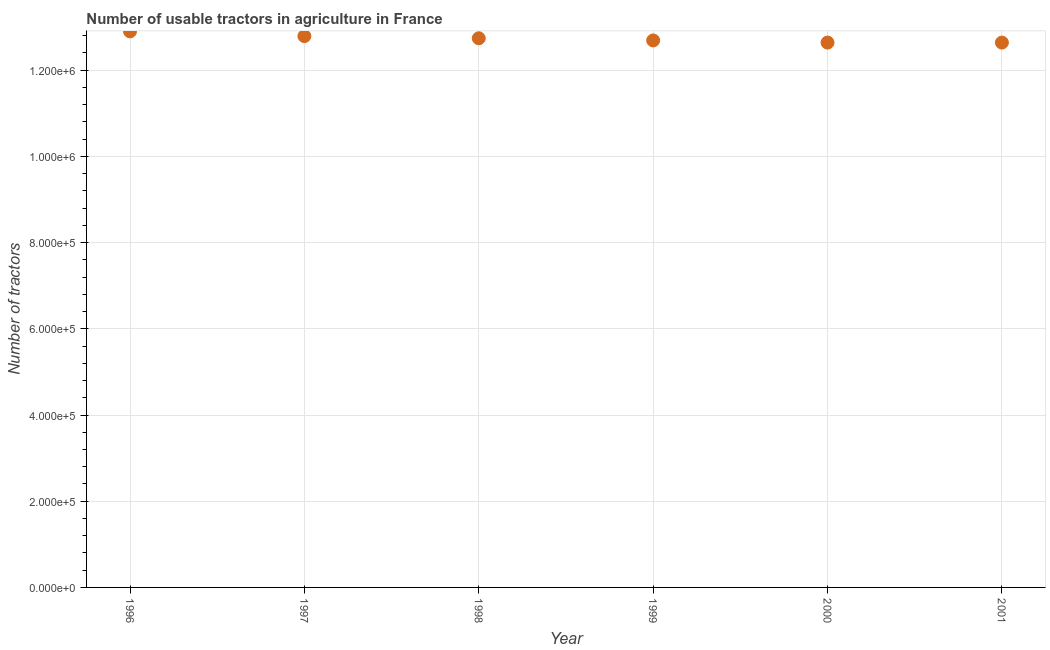What is the number of tractors in 1997?
Your answer should be very brief. 1.28e+06. Across all years, what is the maximum number of tractors?
Your answer should be very brief. 1.29e+06. Across all years, what is the minimum number of tractors?
Ensure brevity in your answer.  1.26e+06. In which year was the number of tractors minimum?
Your response must be concise. 2000. What is the sum of the number of tractors?
Make the answer very short. 7.64e+06. What is the difference between the number of tractors in 1996 and 1997?
Give a very brief answer. 1.10e+04. What is the average number of tractors per year?
Your response must be concise. 1.27e+06. What is the median number of tractors?
Your response must be concise. 1.27e+06. In how many years, is the number of tractors greater than 280000 ?
Offer a terse response. 6. What is the ratio of the number of tractors in 1999 to that in 2000?
Offer a very short reply. 1. What is the difference between the highest and the second highest number of tractors?
Offer a very short reply. 1.10e+04. What is the difference between the highest and the lowest number of tractors?
Your response must be concise. 2.60e+04. In how many years, is the number of tractors greater than the average number of tractors taken over all years?
Provide a succinct answer. 3. Does the number of tractors monotonically increase over the years?
Provide a short and direct response. No. Are the values on the major ticks of Y-axis written in scientific E-notation?
Offer a terse response. Yes. Does the graph contain grids?
Your response must be concise. Yes. What is the title of the graph?
Make the answer very short. Number of usable tractors in agriculture in France. What is the label or title of the Y-axis?
Offer a terse response. Number of tractors. What is the Number of tractors in 1996?
Give a very brief answer. 1.29e+06. What is the Number of tractors in 1997?
Offer a terse response. 1.28e+06. What is the Number of tractors in 1998?
Offer a terse response. 1.27e+06. What is the Number of tractors in 1999?
Offer a very short reply. 1.27e+06. What is the Number of tractors in 2000?
Provide a succinct answer. 1.26e+06. What is the Number of tractors in 2001?
Your answer should be very brief. 1.26e+06. What is the difference between the Number of tractors in 1996 and 1997?
Offer a terse response. 1.10e+04. What is the difference between the Number of tractors in 1996 and 1998?
Your response must be concise. 1.60e+04. What is the difference between the Number of tractors in 1996 and 1999?
Keep it short and to the point. 2.10e+04. What is the difference between the Number of tractors in 1996 and 2000?
Make the answer very short. 2.60e+04. What is the difference between the Number of tractors in 1996 and 2001?
Provide a succinct answer. 2.60e+04. What is the difference between the Number of tractors in 1997 and 1998?
Your answer should be compact. 5000. What is the difference between the Number of tractors in 1997 and 2000?
Your answer should be very brief. 1.50e+04. What is the difference between the Number of tractors in 1997 and 2001?
Your response must be concise. 1.50e+04. What is the difference between the Number of tractors in 1998 and 1999?
Your answer should be very brief. 5000. What is the difference between the Number of tractors in 1998 and 2001?
Your answer should be very brief. 10000. What is the difference between the Number of tractors in 1999 and 2000?
Provide a succinct answer. 5000. What is the difference between the Number of tractors in 1999 and 2001?
Your answer should be compact. 5000. What is the ratio of the Number of tractors in 1996 to that in 1998?
Offer a very short reply. 1.01. What is the ratio of the Number of tractors in 1996 to that in 2000?
Make the answer very short. 1.02. What is the ratio of the Number of tractors in 1997 to that in 1998?
Your answer should be compact. 1. What is the ratio of the Number of tractors in 1997 to that in 2001?
Provide a succinct answer. 1.01. What is the ratio of the Number of tractors in 1998 to that in 1999?
Offer a terse response. 1. What is the ratio of the Number of tractors in 1998 to that in 2000?
Provide a short and direct response. 1.01. What is the ratio of the Number of tractors in 1998 to that in 2001?
Your response must be concise. 1.01. What is the ratio of the Number of tractors in 1999 to that in 2000?
Ensure brevity in your answer.  1. What is the ratio of the Number of tractors in 1999 to that in 2001?
Provide a succinct answer. 1. 